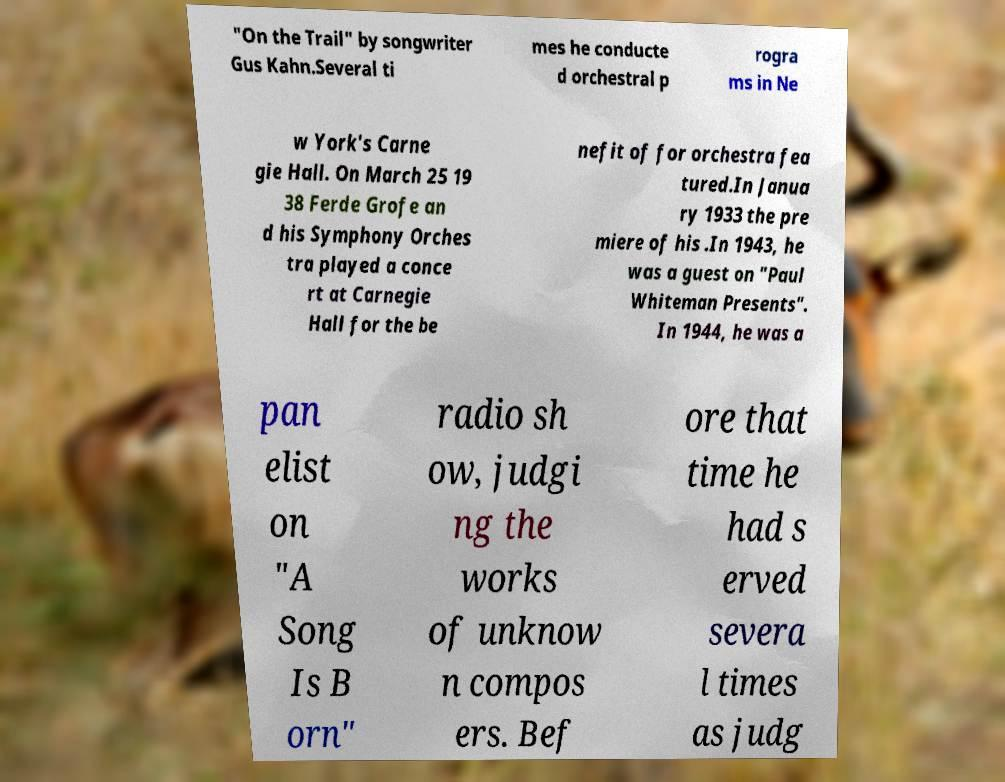Could you assist in decoding the text presented in this image and type it out clearly? "On the Trail" by songwriter Gus Kahn.Several ti mes he conducte d orchestral p rogra ms in Ne w York's Carne gie Hall. On March 25 19 38 Ferde Grofe an d his Symphony Orches tra played a conce rt at Carnegie Hall for the be nefit of for orchestra fea tured.In Janua ry 1933 the pre miere of his .In 1943, he was a guest on "Paul Whiteman Presents". In 1944, he was a pan elist on "A Song Is B orn" radio sh ow, judgi ng the works of unknow n compos ers. Bef ore that time he had s erved severa l times as judg 